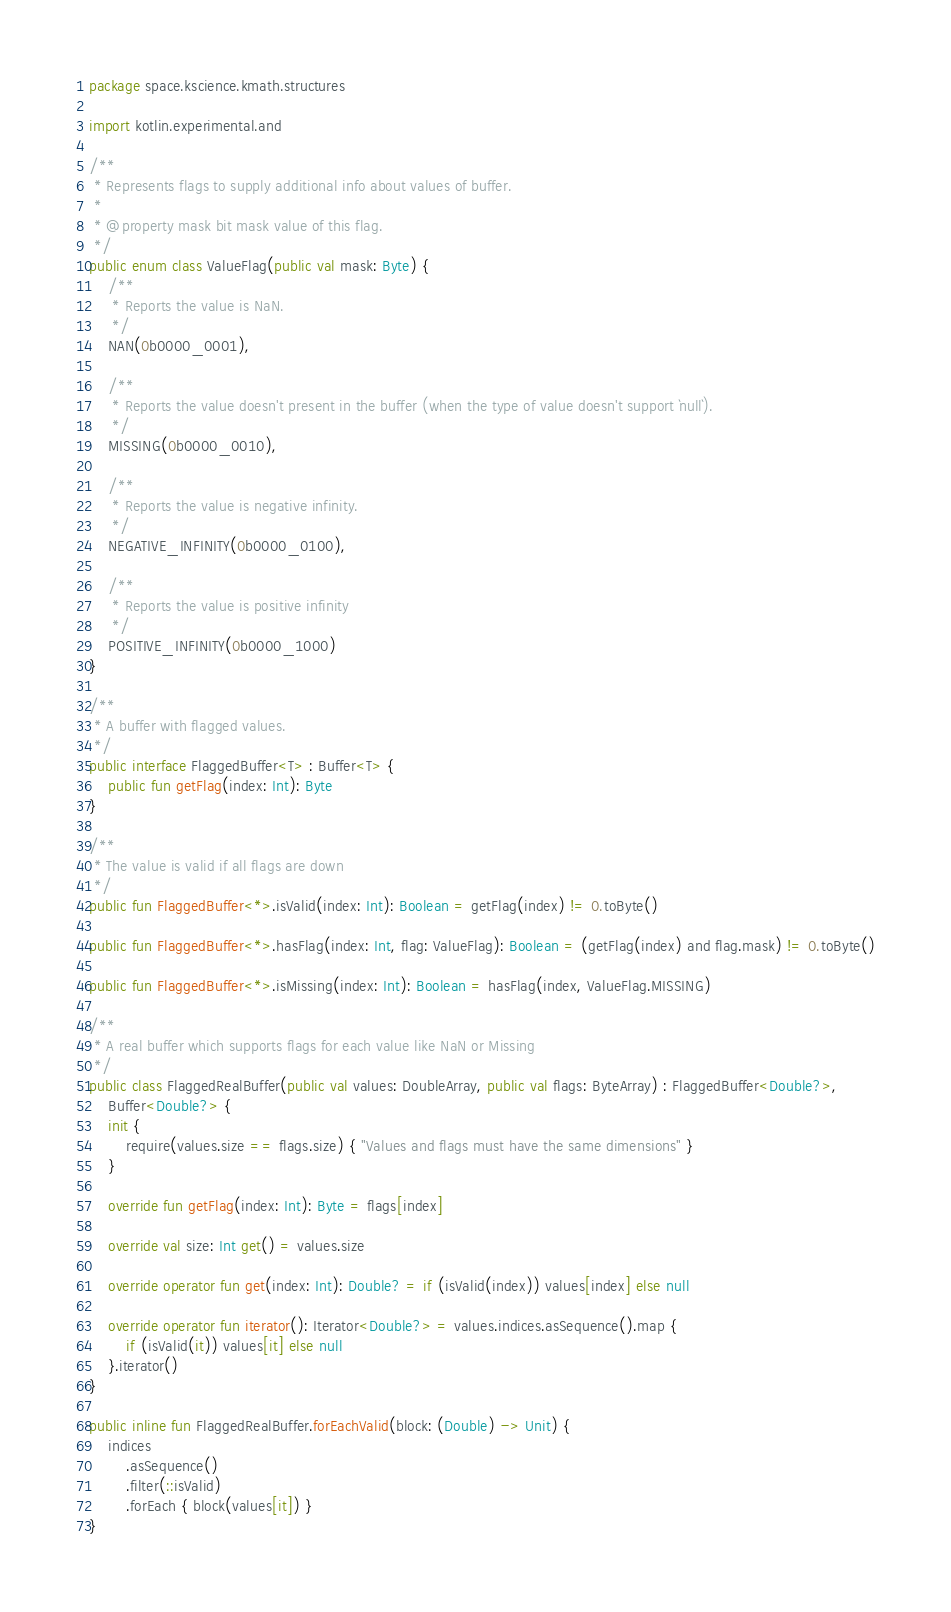<code> <loc_0><loc_0><loc_500><loc_500><_Kotlin_>package space.kscience.kmath.structures

import kotlin.experimental.and

/**
 * Represents flags to supply additional info about values of buffer.
 *
 * @property mask bit mask value of this flag.
 */
public enum class ValueFlag(public val mask: Byte) {
    /**
     * Reports the value is NaN.
     */
    NAN(0b0000_0001),

    /**
     * Reports the value doesn't present in the buffer (when the type of value doesn't support `null`).
     */
    MISSING(0b0000_0010),

    /**
     * Reports the value is negative infinity.
     */
    NEGATIVE_INFINITY(0b0000_0100),

    /**
     * Reports the value is positive infinity
     */
    POSITIVE_INFINITY(0b0000_1000)
}

/**
 * A buffer with flagged values.
 */
public interface FlaggedBuffer<T> : Buffer<T> {
    public fun getFlag(index: Int): Byte
}

/**
 * The value is valid if all flags are down
 */
public fun FlaggedBuffer<*>.isValid(index: Int): Boolean = getFlag(index) != 0.toByte()

public fun FlaggedBuffer<*>.hasFlag(index: Int, flag: ValueFlag): Boolean = (getFlag(index) and flag.mask) != 0.toByte()

public fun FlaggedBuffer<*>.isMissing(index: Int): Boolean = hasFlag(index, ValueFlag.MISSING)

/**
 * A real buffer which supports flags for each value like NaN or Missing
 */
public class FlaggedRealBuffer(public val values: DoubleArray, public val flags: ByteArray) : FlaggedBuffer<Double?>,
    Buffer<Double?> {
    init {
        require(values.size == flags.size) { "Values and flags must have the same dimensions" }
    }

    override fun getFlag(index: Int): Byte = flags[index]

    override val size: Int get() = values.size

    override operator fun get(index: Int): Double? = if (isValid(index)) values[index] else null

    override operator fun iterator(): Iterator<Double?> = values.indices.asSequence().map {
        if (isValid(it)) values[it] else null
    }.iterator()
}

public inline fun FlaggedRealBuffer.forEachValid(block: (Double) -> Unit) {
    indices
        .asSequence()
        .filter(::isValid)
        .forEach { block(values[it]) }
}
</code> 